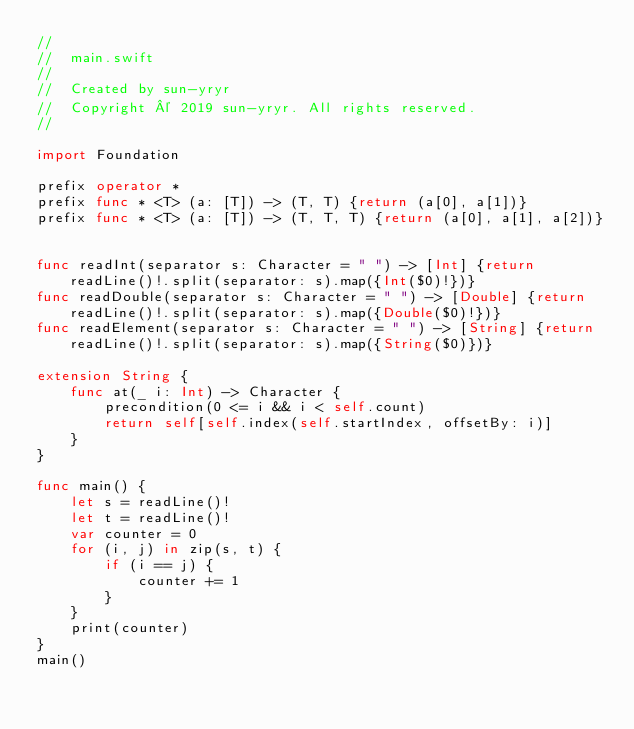Convert code to text. <code><loc_0><loc_0><loc_500><loc_500><_Swift_>//
//  main.swift
//
//  Created by sun-yryr
//  Copyright © 2019 sun-yryr. All rights reserved.
//

import Foundation

prefix operator *
prefix func * <T> (a: [T]) -> (T, T) {return (a[0], a[1])}
prefix func * <T> (a: [T]) -> (T, T, T) {return (a[0], a[1], a[2])}


func readInt(separator s: Character = " ") -> [Int] {return readLine()!.split(separator: s).map({Int($0)!})}
func readDouble(separator s: Character = " ") -> [Double] {return readLine()!.split(separator: s).map({Double($0)!})}
func readElement(separator s: Character = " ") -> [String] {return readLine()!.split(separator: s).map({String($0)})}

extension String {
    func at(_ i: Int) -> Character {
        precondition(0 <= i && i < self.count)
        return self[self.index(self.startIndex, offsetBy: i)]
    }
}

func main() {
    let s = readLine()!
    let t = readLine()!
    var counter = 0
    for (i, j) in zip(s, t) {
        if (i == j) {
            counter += 1
        }
    }
    print(counter)
}
main()
</code> 